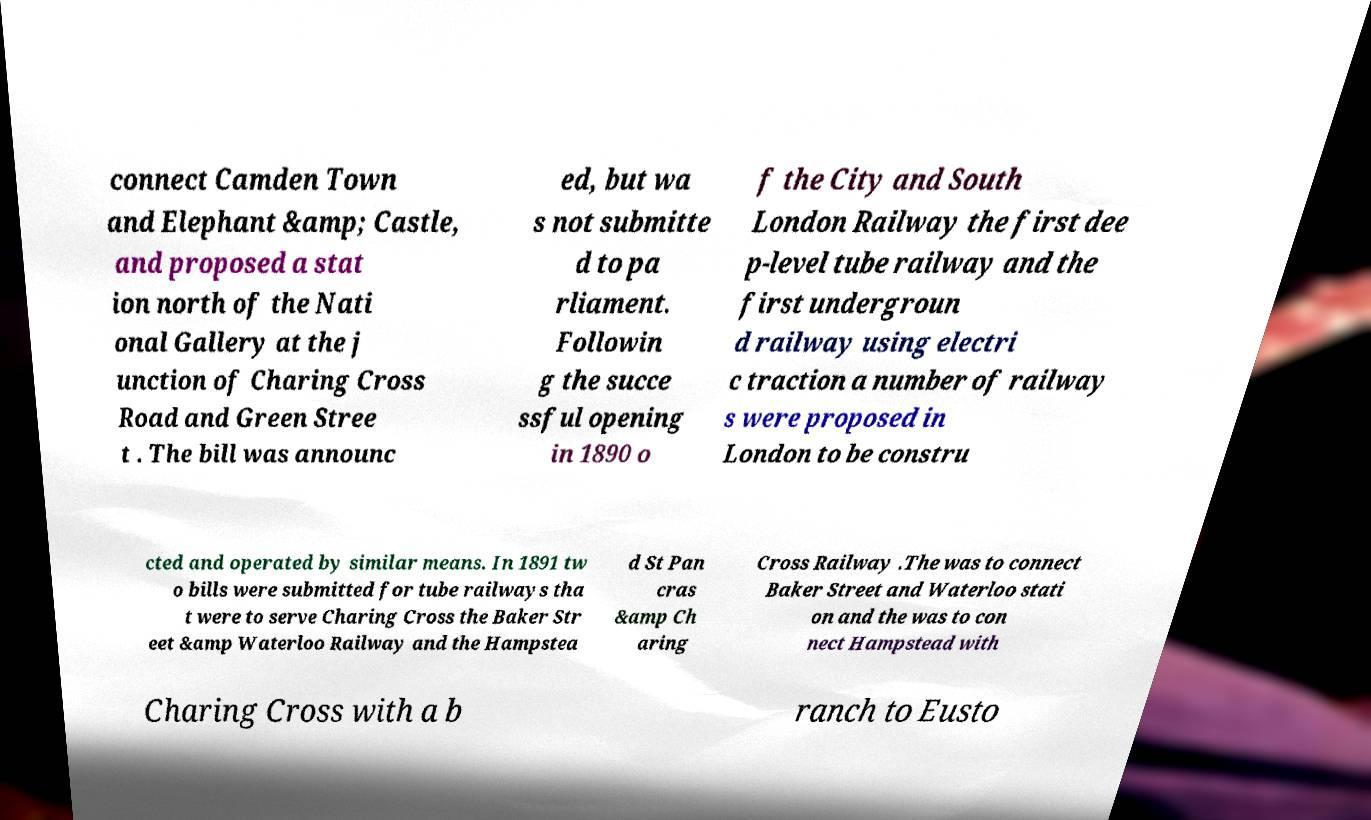Could you assist in decoding the text presented in this image and type it out clearly? connect Camden Town and Elephant &amp; Castle, and proposed a stat ion north of the Nati onal Gallery at the j unction of Charing Cross Road and Green Stree t . The bill was announc ed, but wa s not submitte d to pa rliament. Followin g the succe ssful opening in 1890 o f the City and South London Railway the first dee p-level tube railway and the first undergroun d railway using electri c traction a number of railway s were proposed in London to be constru cted and operated by similar means. In 1891 tw o bills were submitted for tube railways tha t were to serve Charing Cross the Baker Str eet &amp Waterloo Railway and the Hampstea d St Pan cras &amp Ch aring Cross Railway .The was to connect Baker Street and Waterloo stati on and the was to con nect Hampstead with Charing Cross with a b ranch to Eusto 